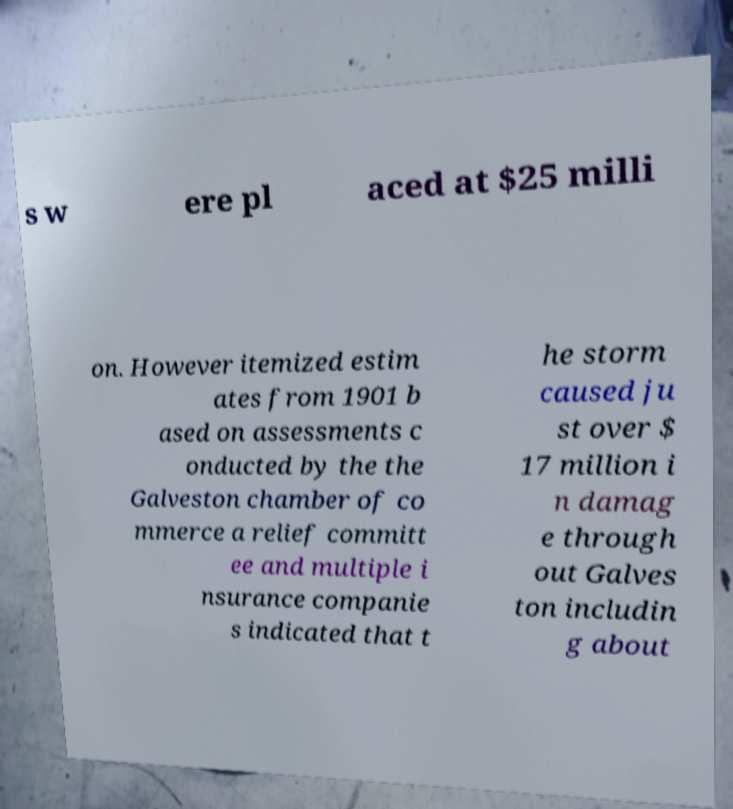Please identify and transcribe the text found in this image. s w ere pl aced at $25 milli on. However itemized estim ates from 1901 b ased on assessments c onducted by the the Galveston chamber of co mmerce a relief committ ee and multiple i nsurance companie s indicated that t he storm caused ju st over $ 17 million i n damag e through out Galves ton includin g about 